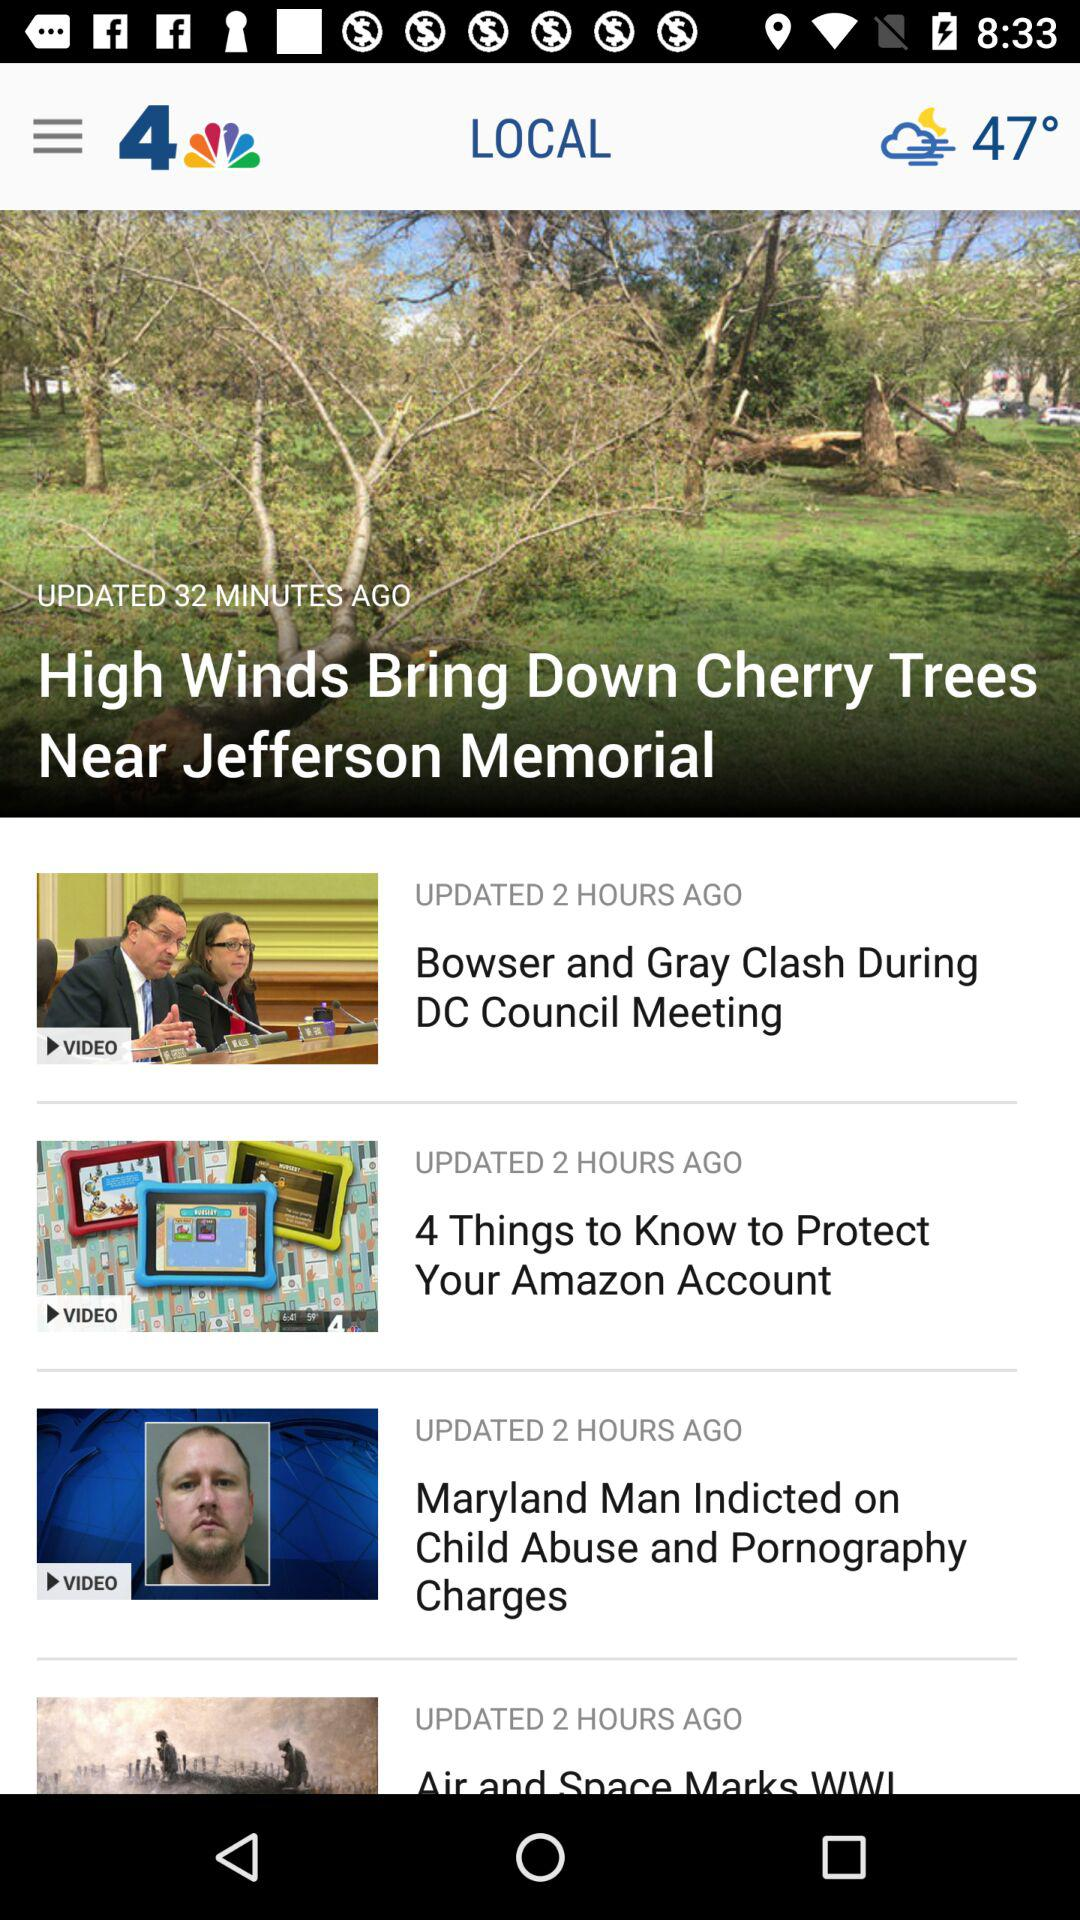When was "4 Things to Know to Protect Your Amazon Account" updated? It was updated 2 hours ago. 